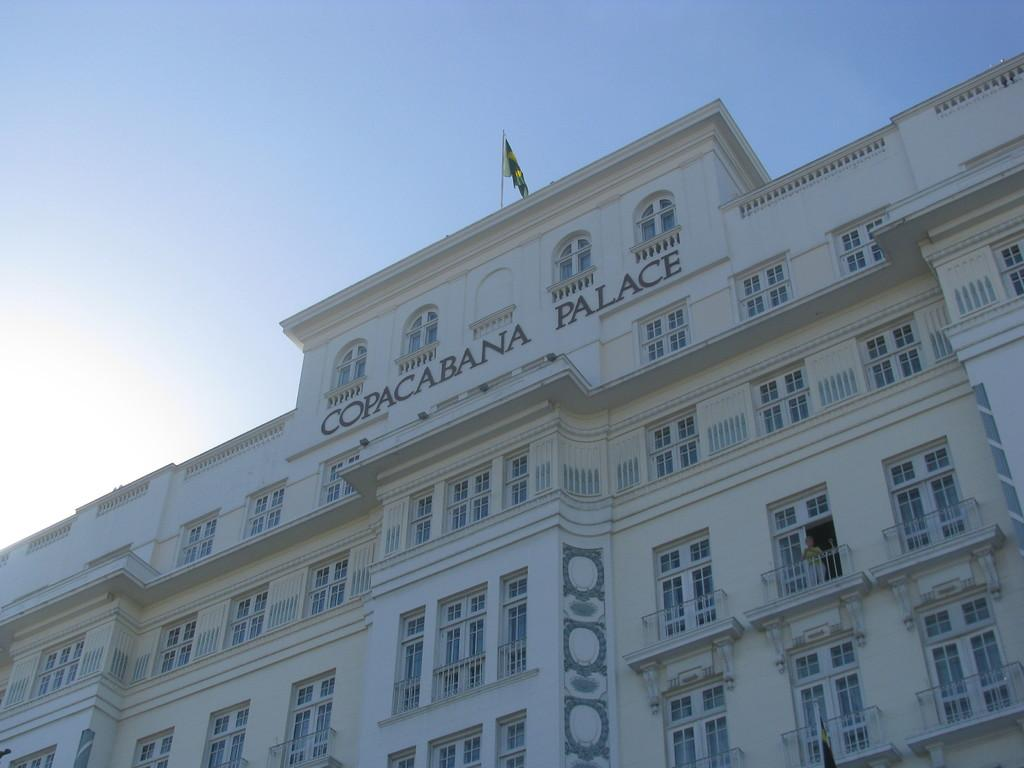What is the main subject of the picture? The main subject of the picture is a building. Is there any text on the building? Yes, the name of the building is written on it. What can be seen on the building's exterior? The building has windows. What is the condition of the sky in the picture? The sky is clear in the picture. How long does it take for the cord to reach the ground from the building in the image? There is no cord present in the image, so it's not possible to determine how long it would take for it to reach the ground. 